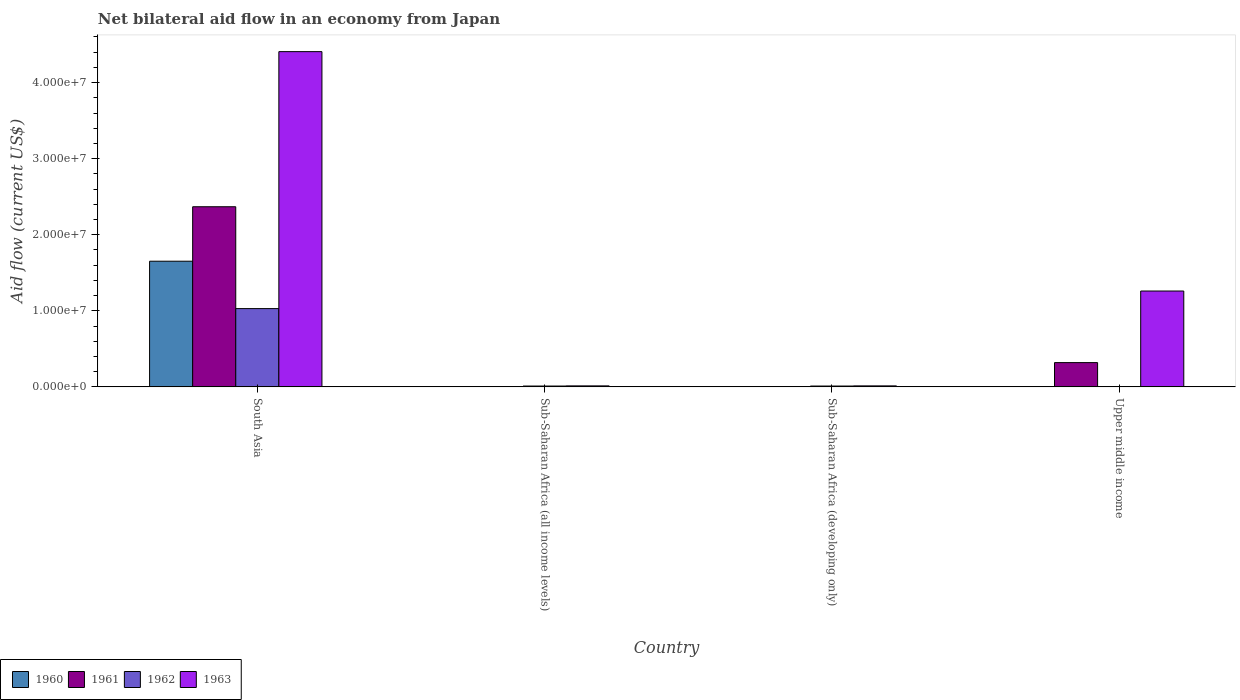How many different coloured bars are there?
Offer a very short reply. 4. How many groups of bars are there?
Keep it short and to the point. 4. Are the number of bars per tick equal to the number of legend labels?
Ensure brevity in your answer.  No. How many bars are there on the 2nd tick from the left?
Your response must be concise. 4. How many bars are there on the 2nd tick from the right?
Make the answer very short. 4. What is the label of the 2nd group of bars from the left?
Ensure brevity in your answer.  Sub-Saharan Africa (all income levels). Across all countries, what is the maximum net bilateral aid flow in 1963?
Ensure brevity in your answer.  4.41e+07. Across all countries, what is the minimum net bilateral aid flow in 1961?
Offer a terse response. 3.00e+04. What is the total net bilateral aid flow in 1961 in the graph?
Make the answer very short. 2.69e+07. What is the difference between the net bilateral aid flow in 1961 in Sub-Saharan Africa (all income levels) and that in Upper middle income?
Your response must be concise. -3.16e+06. What is the difference between the net bilateral aid flow in 1963 in Upper middle income and the net bilateral aid flow in 1960 in Sub-Saharan Africa (developing only)?
Provide a succinct answer. 1.26e+07. What is the average net bilateral aid flow in 1963 per country?
Your response must be concise. 1.42e+07. What is the difference between the net bilateral aid flow of/in 1961 and net bilateral aid flow of/in 1962 in South Asia?
Provide a short and direct response. 1.34e+07. What is the ratio of the net bilateral aid flow in 1963 in South Asia to that in Upper middle income?
Offer a terse response. 3.5. Is the difference between the net bilateral aid flow in 1961 in South Asia and Sub-Saharan Africa (developing only) greater than the difference between the net bilateral aid flow in 1962 in South Asia and Sub-Saharan Africa (developing only)?
Your answer should be compact. Yes. What is the difference between the highest and the second highest net bilateral aid flow in 1960?
Provide a succinct answer. 1.65e+07. What is the difference between the highest and the lowest net bilateral aid flow in 1963?
Provide a succinct answer. 4.39e+07. In how many countries, is the net bilateral aid flow in 1961 greater than the average net bilateral aid flow in 1961 taken over all countries?
Provide a succinct answer. 1. Is the sum of the net bilateral aid flow in 1962 in Sub-Saharan Africa (all income levels) and Sub-Saharan Africa (developing only) greater than the maximum net bilateral aid flow in 1960 across all countries?
Provide a short and direct response. No. Is it the case that in every country, the sum of the net bilateral aid flow in 1961 and net bilateral aid flow in 1963 is greater than the sum of net bilateral aid flow in 1962 and net bilateral aid flow in 1960?
Your response must be concise. No. Are all the bars in the graph horizontal?
Your answer should be compact. No. What is the difference between two consecutive major ticks on the Y-axis?
Offer a terse response. 1.00e+07. Where does the legend appear in the graph?
Keep it short and to the point. Bottom left. How are the legend labels stacked?
Give a very brief answer. Horizontal. What is the title of the graph?
Ensure brevity in your answer.  Net bilateral aid flow in an economy from Japan. Does "1987" appear as one of the legend labels in the graph?
Give a very brief answer. No. What is the Aid flow (current US$) in 1960 in South Asia?
Give a very brief answer. 1.65e+07. What is the Aid flow (current US$) in 1961 in South Asia?
Provide a short and direct response. 2.37e+07. What is the Aid flow (current US$) in 1962 in South Asia?
Ensure brevity in your answer.  1.03e+07. What is the Aid flow (current US$) in 1963 in South Asia?
Provide a succinct answer. 4.41e+07. What is the Aid flow (current US$) of 1961 in Sub-Saharan Africa (all income levels)?
Make the answer very short. 3.00e+04. What is the Aid flow (current US$) of 1962 in Sub-Saharan Africa (all income levels)?
Your answer should be very brief. 1.10e+05. What is the Aid flow (current US$) in 1963 in Sub-Saharan Africa (all income levels)?
Provide a short and direct response. 1.30e+05. What is the Aid flow (current US$) in 1960 in Sub-Saharan Africa (developing only)?
Ensure brevity in your answer.  2.00e+04. What is the Aid flow (current US$) of 1962 in Sub-Saharan Africa (developing only)?
Give a very brief answer. 1.10e+05. What is the Aid flow (current US$) in 1963 in Sub-Saharan Africa (developing only)?
Make the answer very short. 1.30e+05. What is the Aid flow (current US$) in 1960 in Upper middle income?
Keep it short and to the point. 0. What is the Aid flow (current US$) in 1961 in Upper middle income?
Provide a short and direct response. 3.19e+06. What is the Aid flow (current US$) of 1962 in Upper middle income?
Offer a terse response. 0. What is the Aid flow (current US$) in 1963 in Upper middle income?
Make the answer very short. 1.26e+07. Across all countries, what is the maximum Aid flow (current US$) in 1960?
Keep it short and to the point. 1.65e+07. Across all countries, what is the maximum Aid flow (current US$) of 1961?
Your answer should be very brief. 2.37e+07. Across all countries, what is the maximum Aid flow (current US$) in 1962?
Offer a very short reply. 1.03e+07. Across all countries, what is the maximum Aid flow (current US$) of 1963?
Provide a short and direct response. 4.41e+07. Across all countries, what is the minimum Aid flow (current US$) in 1960?
Give a very brief answer. 0. What is the total Aid flow (current US$) of 1960 in the graph?
Ensure brevity in your answer.  1.66e+07. What is the total Aid flow (current US$) of 1961 in the graph?
Ensure brevity in your answer.  2.69e+07. What is the total Aid flow (current US$) in 1962 in the graph?
Your answer should be very brief. 1.05e+07. What is the total Aid flow (current US$) in 1963 in the graph?
Your answer should be compact. 5.69e+07. What is the difference between the Aid flow (current US$) in 1960 in South Asia and that in Sub-Saharan Africa (all income levels)?
Your answer should be compact. 1.65e+07. What is the difference between the Aid flow (current US$) of 1961 in South Asia and that in Sub-Saharan Africa (all income levels)?
Give a very brief answer. 2.36e+07. What is the difference between the Aid flow (current US$) of 1962 in South Asia and that in Sub-Saharan Africa (all income levels)?
Give a very brief answer. 1.02e+07. What is the difference between the Aid flow (current US$) of 1963 in South Asia and that in Sub-Saharan Africa (all income levels)?
Your answer should be very brief. 4.39e+07. What is the difference between the Aid flow (current US$) of 1960 in South Asia and that in Sub-Saharan Africa (developing only)?
Offer a very short reply. 1.65e+07. What is the difference between the Aid flow (current US$) in 1961 in South Asia and that in Sub-Saharan Africa (developing only)?
Provide a short and direct response. 2.36e+07. What is the difference between the Aid flow (current US$) of 1962 in South Asia and that in Sub-Saharan Africa (developing only)?
Ensure brevity in your answer.  1.02e+07. What is the difference between the Aid flow (current US$) in 1963 in South Asia and that in Sub-Saharan Africa (developing only)?
Offer a very short reply. 4.39e+07. What is the difference between the Aid flow (current US$) of 1961 in South Asia and that in Upper middle income?
Make the answer very short. 2.05e+07. What is the difference between the Aid flow (current US$) in 1963 in South Asia and that in Upper middle income?
Make the answer very short. 3.15e+07. What is the difference between the Aid flow (current US$) in 1960 in Sub-Saharan Africa (all income levels) and that in Sub-Saharan Africa (developing only)?
Your answer should be very brief. 0. What is the difference between the Aid flow (current US$) of 1961 in Sub-Saharan Africa (all income levels) and that in Upper middle income?
Your answer should be very brief. -3.16e+06. What is the difference between the Aid flow (current US$) in 1963 in Sub-Saharan Africa (all income levels) and that in Upper middle income?
Offer a very short reply. -1.25e+07. What is the difference between the Aid flow (current US$) in 1961 in Sub-Saharan Africa (developing only) and that in Upper middle income?
Your response must be concise. -3.16e+06. What is the difference between the Aid flow (current US$) of 1963 in Sub-Saharan Africa (developing only) and that in Upper middle income?
Give a very brief answer. -1.25e+07. What is the difference between the Aid flow (current US$) in 1960 in South Asia and the Aid flow (current US$) in 1961 in Sub-Saharan Africa (all income levels)?
Your response must be concise. 1.65e+07. What is the difference between the Aid flow (current US$) in 1960 in South Asia and the Aid flow (current US$) in 1962 in Sub-Saharan Africa (all income levels)?
Provide a short and direct response. 1.64e+07. What is the difference between the Aid flow (current US$) of 1960 in South Asia and the Aid flow (current US$) of 1963 in Sub-Saharan Africa (all income levels)?
Provide a succinct answer. 1.64e+07. What is the difference between the Aid flow (current US$) of 1961 in South Asia and the Aid flow (current US$) of 1962 in Sub-Saharan Africa (all income levels)?
Offer a terse response. 2.36e+07. What is the difference between the Aid flow (current US$) of 1961 in South Asia and the Aid flow (current US$) of 1963 in Sub-Saharan Africa (all income levels)?
Provide a short and direct response. 2.36e+07. What is the difference between the Aid flow (current US$) in 1962 in South Asia and the Aid flow (current US$) in 1963 in Sub-Saharan Africa (all income levels)?
Provide a short and direct response. 1.02e+07. What is the difference between the Aid flow (current US$) in 1960 in South Asia and the Aid flow (current US$) in 1961 in Sub-Saharan Africa (developing only)?
Ensure brevity in your answer.  1.65e+07. What is the difference between the Aid flow (current US$) in 1960 in South Asia and the Aid flow (current US$) in 1962 in Sub-Saharan Africa (developing only)?
Ensure brevity in your answer.  1.64e+07. What is the difference between the Aid flow (current US$) in 1960 in South Asia and the Aid flow (current US$) in 1963 in Sub-Saharan Africa (developing only)?
Make the answer very short. 1.64e+07. What is the difference between the Aid flow (current US$) in 1961 in South Asia and the Aid flow (current US$) in 1962 in Sub-Saharan Africa (developing only)?
Ensure brevity in your answer.  2.36e+07. What is the difference between the Aid flow (current US$) of 1961 in South Asia and the Aid flow (current US$) of 1963 in Sub-Saharan Africa (developing only)?
Make the answer very short. 2.36e+07. What is the difference between the Aid flow (current US$) of 1962 in South Asia and the Aid flow (current US$) of 1963 in Sub-Saharan Africa (developing only)?
Ensure brevity in your answer.  1.02e+07. What is the difference between the Aid flow (current US$) in 1960 in South Asia and the Aid flow (current US$) in 1961 in Upper middle income?
Make the answer very short. 1.33e+07. What is the difference between the Aid flow (current US$) in 1960 in South Asia and the Aid flow (current US$) in 1963 in Upper middle income?
Your answer should be compact. 3.92e+06. What is the difference between the Aid flow (current US$) of 1961 in South Asia and the Aid flow (current US$) of 1963 in Upper middle income?
Your answer should be very brief. 1.11e+07. What is the difference between the Aid flow (current US$) of 1962 in South Asia and the Aid flow (current US$) of 1963 in Upper middle income?
Keep it short and to the point. -2.31e+06. What is the difference between the Aid flow (current US$) of 1960 in Sub-Saharan Africa (all income levels) and the Aid flow (current US$) of 1961 in Sub-Saharan Africa (developing only)?
Your answer should be compact. -10000. What is the difference between the Aid flow (current US$) in 1960 in Sub-Saharan Africa (all income levels) and the Aid flow (current US$) in 1962 in Sub-Saharan Africa (developing only)?
Your answer should be compact. -9.00e+04. What is the difference between the Aid flow (current US$) in 1960 in Sub-Saharan Africa (all income levels) and the Aid flow (current US$) in 1961 in Upper middle income?
Your answer should be compact. -3.17e+06. What is the difference between the Aid flow (current US$) in 1960 in Sub-Saharan Africa (all income levels) and the Aid flow (current US$) in 1963 in Upper middle income?
Provide a short and direct response. -1.26e+07. What is the difference between the Aid flow (current US$) in 1961 in Sub-Saharan Africa (all income levels) and the Aid flow (current US$) in 1963 in Upper middle income?
Ensure brevity in your answer.  -1.26e+07. What is the difference between the Aid flow (current US$) of 1962 in Sub-Saharan Africa (all income levels) and the Aid flow (current US$) of 1963 in Upper middle income?
Provide a succinct answer. -1.25e+07. What is the difference between the Aid flow (current US$) in 1960 in Sub-Saharan Africa (developing only) and the Aid flow (current US$) in 1961 in Upper middle income?
Offer a very short reply. -3.17e+06. What is the difference between the Aid flow (current US$) of 1960 in Sub-Saharan Africa (developing only) and the Aid flow (current US$) of 1963 in Upper middle income?
Provide a succinct answer. -1.26e+07. What is the difference between the Aid flow (current US$) in 1961 in Sub-Saharan Africa (developing only) and the Aid flow (current US$) in 1963 in Upper middle income?
Offer a terse response. -1.26e+07. What is the difference between the Aid flow (current US$) in 1962 in Sub-Saharan Africa (developing only) and the Aid flow (current US$) in 1963 in Upper middle income?
Give a very brief answer. -1.25e+07. What is the average Aid flow (current US$) of 1960 per country?
Give a very brief answer. 4.14e+06. What is the average Aid flow (current US$) in 1961 per country?
Your answer should be compact. 6.73e+06. What is the average Aid flow (current US$) of 1962 per country?
Provide a short and direct response. 2.63e+06. What is the average Aid flow (current US$) in 1963 per country?
Keep it short and to the point. 1.42e+07. What is the difference between the Aid flow (current US$) in 1960 and Aid flow (current US$) in 1961 in South Asia?
Your response must be concise. -7.16e+06. What is the difference between the Aid flow (current US$) of 1960 and Aid flow (current US$) of 1962 in South Asia?
Offer a terse response. 6.23e+06. What is the difference between the Aid flow (current US$) of 1960 and Aid flow (current US$) of 1963 in South Asia?
Ensure brevity in your answer.  -2.76e+07. What is the difference between the Aid flow (current US$) of 1961 and Aid flow (current US$) of 1962 in South Asia?
Provide a short and direct response. 1.34e+07. What is the difference between the Aid flow (current US$) in 1961 and Aid flow (current US$) in 1963 in South Asia?
Your answer should be very brief. -2.04e+07. What is the difference between the Aid flow (current US$) of 1962 and Aid flow (current US$) of 1963 in South Asia?
Give a very brief answer. -3.38e+07. What is the difference between the Aid flow (current US$) in 1960 and Aid flow (current US$) in 1961 in Sub-Saharan Africa (all income levels)?
Ensure brevity in your answer.  -10000. What is the difference between the Aid flow (current US$) of 1960 and Aid flow (current US$) of 1963 in Sub-Saharan Africa (all income levels)?
Your answer should be compact. -1.10e+05. What is the difference between the Aid flow (current US$) in 1962 and Aid flow (current US$) in 1963 in Sub-Saharan Africa (all income levels)?
Your response must be concise. -2.00e+04. What is the difference between the Aid flow (current US$) in 1960 and Aid flow (current US$) in 1963 in Sub-Saharan Africa (developing only)?
Make the answer very short. -1.10e+05. What is the difference between the Aid flow (current US$) of 1961 and Aid flow (current US$) of 1962 in Sub-Saharan Africa (developing only)?
Offer a very short reply. -8.00e+04. What is the difference between the Aid flow (current US$) of 1961 and Aid flow (current US$) of 1963 in Sub-Saharan Africa (developing only)?
Offer a terse response. -1.00e+05. What is the difference between the Aid flow (current US$) of 1961 and Aid flow (current US$) of 1963 in Upper middle income?
Your response must be concise. -9.41e+06. What is the ratio of the Aid flow (current US$) in 1960 in South Asia to that in Sub-Saharan Africa (all income levels)?
Your answer should be very brief. 826. What is the ratio of the Aid flow (current US$) of 1961 in South Asia to that in Sub-Saharan Africa (all income levels)?
Give a very brief answer. 789.33. What is the ratio of the Aid flow (current US$) of 1962 in South Asia to that in Sub-Saharan Africa (all income levels)?
Make the answer very short. 93.55. What is the ratio of the Aid flow (current US$) of 1963 in South Asia to that in Sub-Saharan Africa (all income levels)?
Your answer should be very brief. 339. What is the ratio of the Aid flow (current US$) in 1960 in South Asia to that in Sub-Saharan Africa (developing only)?
Keep it short and to the point. 826. What is the ratio of the Aid flow (current US$) of 1961 in South Asia to that in Sub-Saharan Africa (developing only)?
Give a very brief answer. 789.33. What is the ratio of the Aid flow (current US$) in 1962 in South Asia to that in Sub-Saharan Africa (developing only)?
Make the answer very short. 93.55. What is the ratio of the Aid flow (current US$) in 1963 in South Asia to that in Sub-Saharan Africa (developing only)?
Provide a short and direct response. 339. What is the ratio of the Aid flow (current US$) in 1961 in South Asia to that in Upper middle income?
Give a very brief answer. 7.42. What is the ratio of the Aid flow (current US$) in 1963 in South Asia to that in Upper middle income?
Provide a short and direct response. 3.5. What is the ratio of the Aid flow (current US$) in 1961 in Sub-Saharan Africa (all income levels) to that in Sub-Saharan Africa (developing only)?
Your answer should be compact. 1. What is the ratio of the Aid flow (current US$) of 1961 in Sub-Saharan Africa (all income levels) to that in Upper middle income?
Offer a very short reply. 0.01. What is the ratio of the Aid flow (current US$) of 1963 in Sub-Saharan Africa (all income levels) to that in Upper middle income?
Keep it short and to the point. 0.01. What is the ratio of the Aid flow (current US$) in 1961 in Sub-Saharan Africa (developing only) to that in Upper middle income?
Your answer should be compact. 0.01. What is the ratio of the Aid flow (current US$) in 1963 in Sub-Saharan Africa (developing only) to that in Upper middle income?
Keep it short and to the point. 0.01. What is the difference between the highest and the second highest Aid flow (current US$) of 1960?
Make the answer very short. 1.65e+07. What is the difference between the highest and the second highest Aid flow (current US$) of 1961?
Ensure brevity in your answer.  2.05e+07. What is the difference between the highest and the second highest Aid flow (current US$) of 1962?
Ensure brevity in your answer.  1.02e+07. What is the difference between the highest and the second highest Aid flow (current US$) in 1963?
Offer a terse response. 3.15e+07. What is the difference between the highest and the lowest Aid flow (current US$) in 1960?
Keep it short and to the point. 1.65e+07. What is the difference between the highest and the lowest Aid flow (current US$) of 1961?
Offer a terse response. 2.36e+07. What is the difference between the highest and the lowest Aid flow (current US$) in 1962?
Provide a succinct answer. 1.03e+07. What is the difference between the highest and the lowest Aid flow (current US$) of 1963?
Your answer should be very brief. 4.39e+07. 